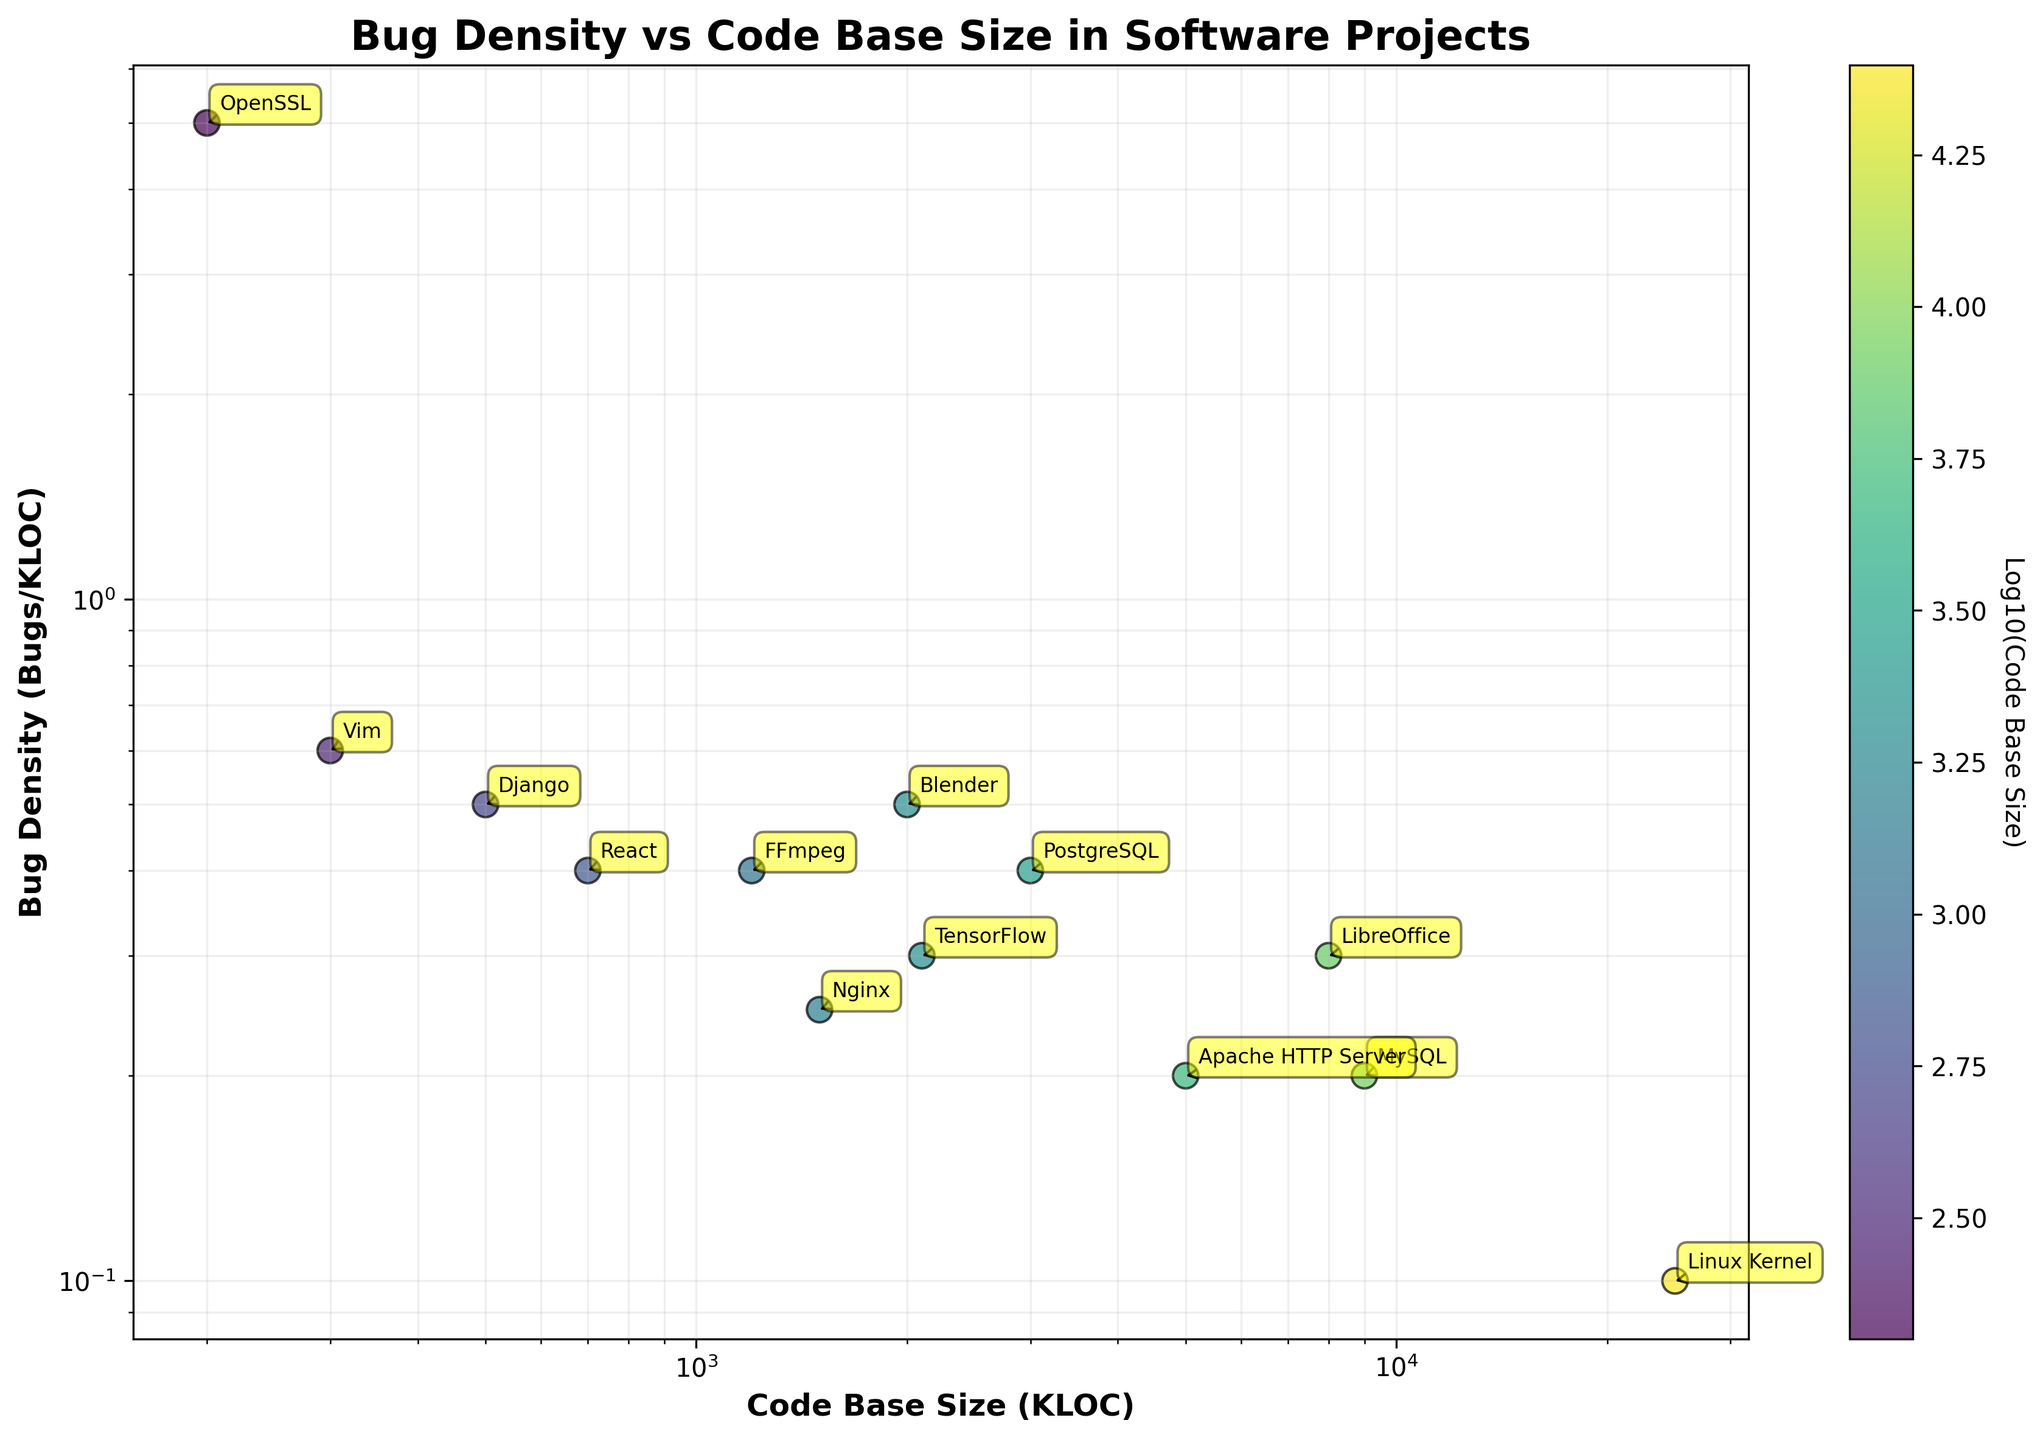What is the title of the plot? The title is located at the top of the figure and is often the first thing read when interpreting the graph.
Answer: Bug Density vs Code Base Size in Software Projects What is the x-axis representing in the plot? The x-axis is labeled and provides information about the data dimension it represents.
Answer: Code Base Size (KLOC) Which project has the highest Bug Density? By looking at the y-values for Bug Density, the highest point on the y-axis indicates the highest Bug Density.
Answer: Vim How does Bug Density change as Code Base Size increases? By analyzing the scatter plot, observe the general trend of the data points. Most smaller projects tend to have higher Bug Densities and larger projects show lower Bug Densities.
Answer: Generally decreases Which project has a Code Base Size of 200 KLOC? Check the annotated labels and corresponding x-values to identify the project with 200 KLOC.
Answer: OpenSSL How many projects have a Bug Density greater than 0.4? By visually identifying the data points with y-values above 0.4 and counting them.
Answer: Four projects Compare the Bug Density of the Linux Kernel and MySQL. Which one is higher? Find the positions of both projects on the y-axis and compare their Bug Density values.
Answer: MySQL What is the relationship between Code Base Size and Bug Density for TensorFlow compared to PostgreSQL? Find both projects on the plot, compare their x (Code Base Size) and y-values (Bug Density). TensorFlow has a larger Code Base Size and slightly lower Bug Density compared to PostgreSQL.
Answer: TensorFlow: larger, lower density Is there any clustering of projects with similar Bug Densities? Look for groups of data points that are close together on the y-axis, visually check for clustering.
Answer: Yes, several projects cluster around 0.4-0.5 What does the color gradient represent in the plot? The legend or color bar provides information on what the colors encode.
Answer: Log10(Code Base Size) Which projects have Code Base Sizes that are close to 1000 KLOC? Identify projects with x-values around 1000 KLOC and cross-reference their labels.
Answer: FFmpeg and Nginx 